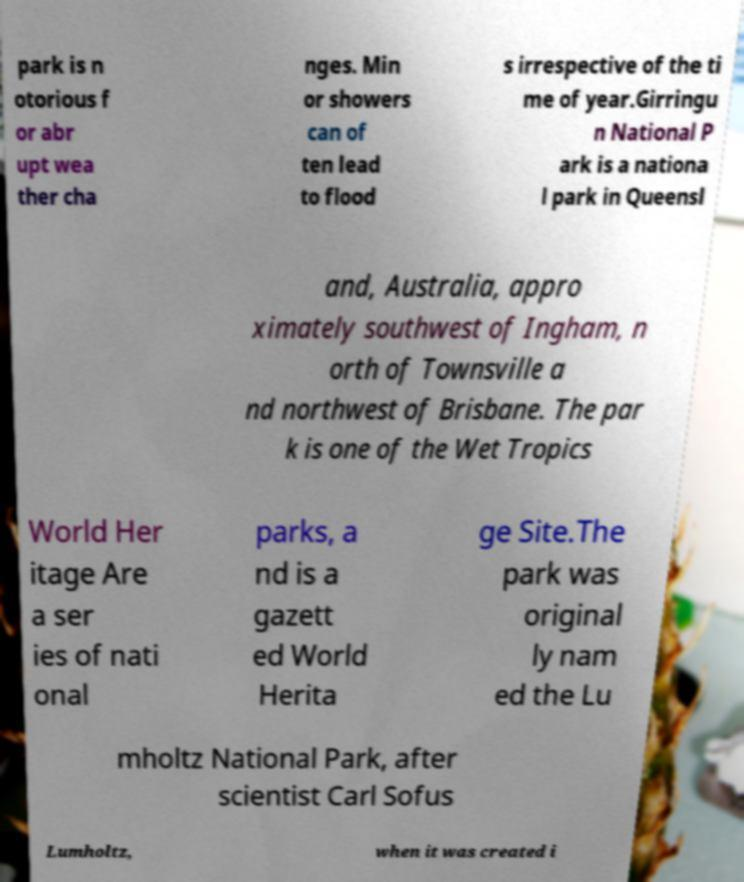Could you extract and type out the text from this image? park is n otorious f or abr upt wea ther cha nges. Min or showers can of ten lead to flood s irrespective of the ti me of year.Girringu n National P ark is a nationa l park in Queensl and, Australia, appro ximately southwest of Ingham, n orth of Townsville a nd northwest of Brisbane. The par k is one of the Wet Tropics World Her itage Are a ser ies of nati onal parks, a nd is a gazett ed World Herita ge Site.The park was original ly nam ed the Lu mholtz National Park, after scientist Carl Sofus Lumholtz, when it was created i 